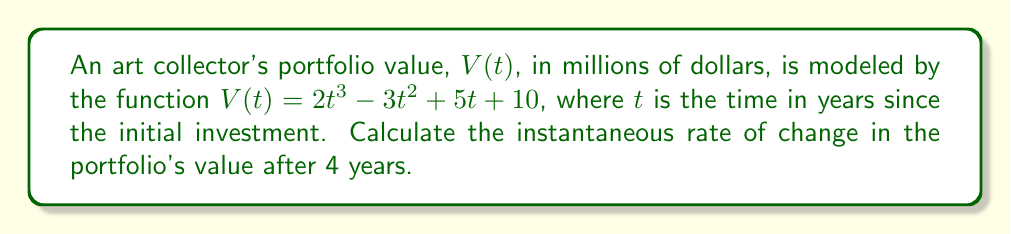Show me your answer to this math problem. To find the instantaneous rate of change after 4 years, we need to calculate the derivative of $V(t)$ and evaluate it at $t=4$:

1) First, let's find the derivative of $V(t)$:
   $$V'(t) = \frac{d}{dt}(2t^3 - 3t^2 + 5t + 10)$$
   $$V'(t) = 6t^2 - 6t + 5$$

2) Now, we evaluate $V'(t)$ at $t=4$:
   $$V'(4) = 6(4)^2 - 6(4) + 5$$
   $$V'(4) = 6(16) - 24 + 5$$
   $$V'(4) = 96 - 24 + 5$$
   $$V'(4) = 77$$

3) The units of this rate of change are millions of dollars per year.

Therefore, the instantaneous rate of change in the portfolio's value after 4 years is 77 million dollars per year.
Answer: $77$ million dollars per year 